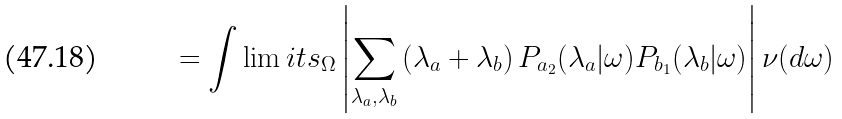<formula> <loc_0><loc_0><loc_500><loc_500>= \int \lim i t s _ { \Omega } \left | \sum _ { \lambda _ { a } , \lambda _ { b } } \left ( \lambda _ { a } + \lambda _ { b } \right ) P _ { a _ { 2 } } ( \lambda _ { a } | \omega ) P _ { b _ { 1 } } ( \lambda _ { b } | \omega ) \right | \nu ( d \omega )</formula> 